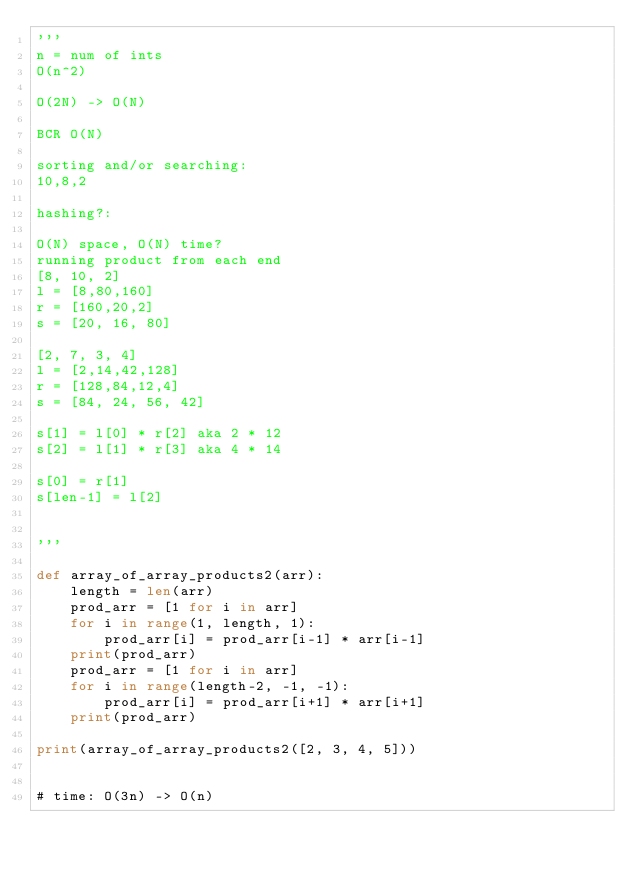Convert code to text. <code><loc_0><loc_0><loc_500><loc_500><_Python_>'''
n = num of ints
O(n^2)

O(2N) -> O(N)

BCR O(N)

sorting and/or searching:
10,8,2

hashing?:

O(N) space, O(N) time?
running product from each end
[8, 10, 2]
l = [8,80,160]
r = [160,20,2]
s = [20, 16, 80]

[2, 7, 3, 4]
l = [2,14,42,128]
r = [128,84,12,4]
s = [84, 24, 56, 42]

s[1] = l[0] * r[2] aka 2 * 12
s[2] = l[1] * r[3] aka 4 * 14

s[0] = r[1]
s[len-1] = l[2]


'''

def array_of_array_products2(arr):
	length = len(arr)
	prod_arr = [1 for i in arr]
	for i in range(1, length, 1):
		prod_arr[i] = prod_arr[i-1] * arr[i-1]
	print(prod_arr)
	prod_arr = [1 for i in arr]
	for i in range(length-2, -1, -1):
		prod_arr[i] = prod_arr[i+1] * arr[i+1]
	print(prod_arr)

print(array_of_array_products2([2, 3, 4, 5]))


# time: O(3n) -> O(n)</code> 